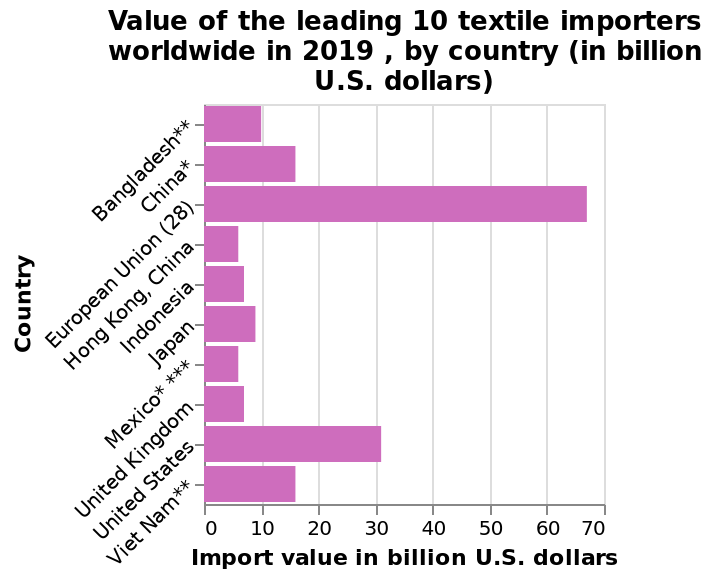<image>
Which country tied with China as the lowest value textile importer in 2019? Mexico tied with China as the lowest value textile importer in 2019. Which two countries tied for being the lowest value textile importers in 2019?  China and Mexico were tied for being the lowest value textile importers in 2019. 